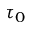Convert formula to latex. <formula><loc_0><loc_0><loc_500><loc_500>\tau _ { 0 }</formula> 